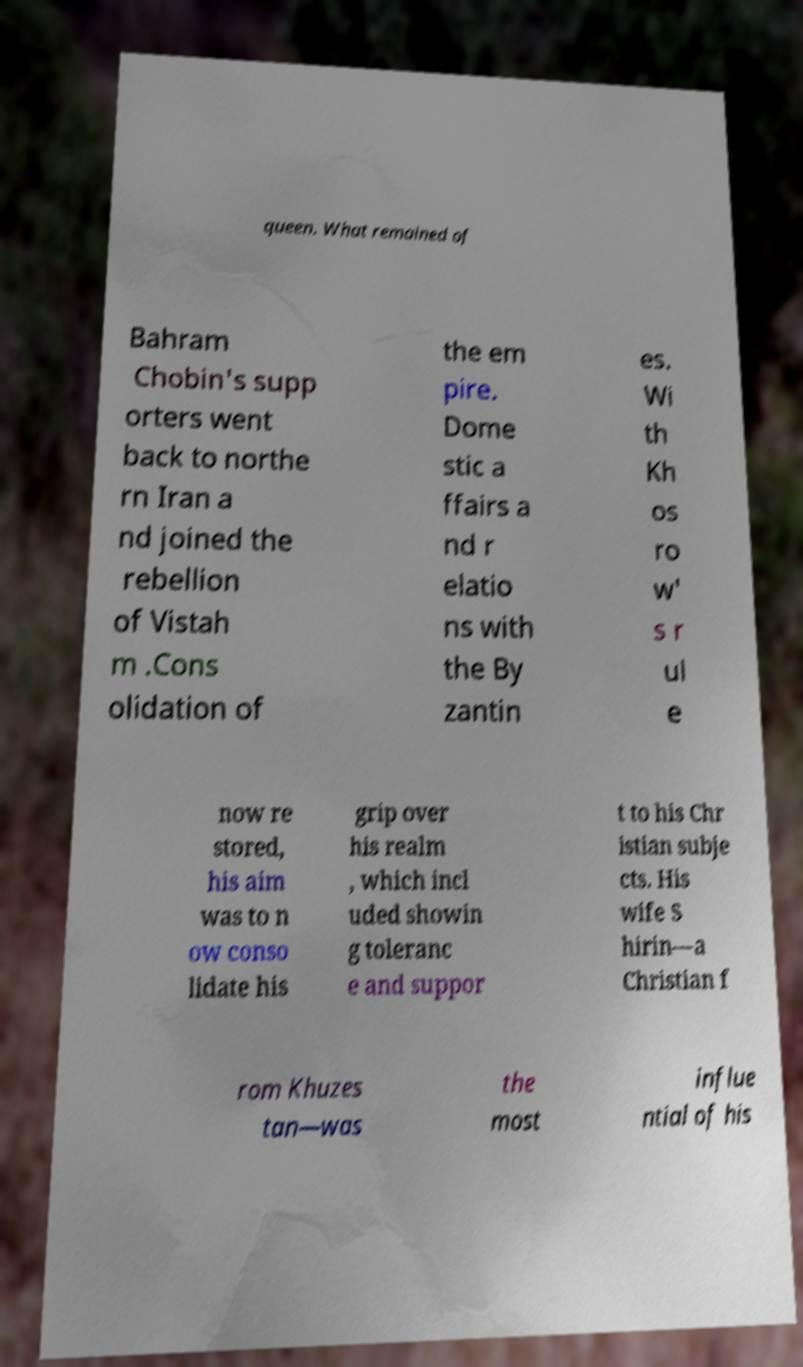For documentation purposes, I need the text within this image transcribed. Could you provide that? queen. What remained of Bahram Chobin's supp orters went back to northe rn Iran a nd joined the rebellion of Vistah m .Cons olidation of the em pire. Dome stic a ffairs a nd r elatio ns with the By zantin es. Wi th Kh os ro w' s r ul e now re stored, his aim was to n ow conso lidate his grip over his realm , which incl uded showin g toleranc e and suppor t to his Chr istian subje cts. His wife S hirin—a Christian f rom Khuzes tan—was the most influe ntial of his 